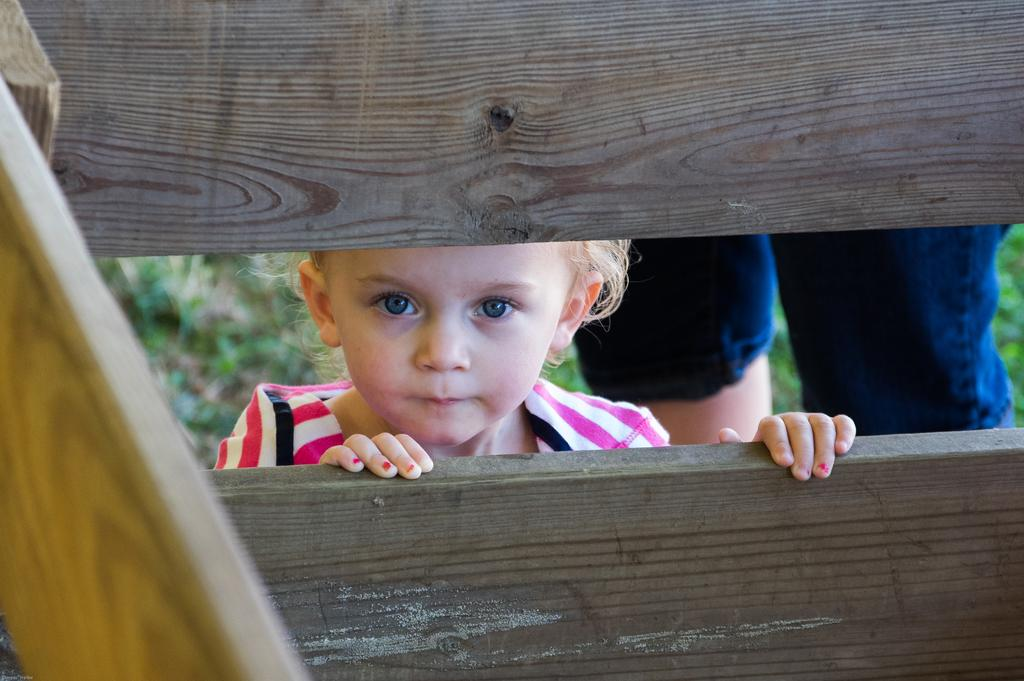Who is the main subject in the image? There is a small girl in the image. Where is the girl located in the image? The girl is in the center of the image. What type of joke is the girl telling in the image? There is no indication in the image that the girl is telling a joke, so it cannot be determined from the picture. 